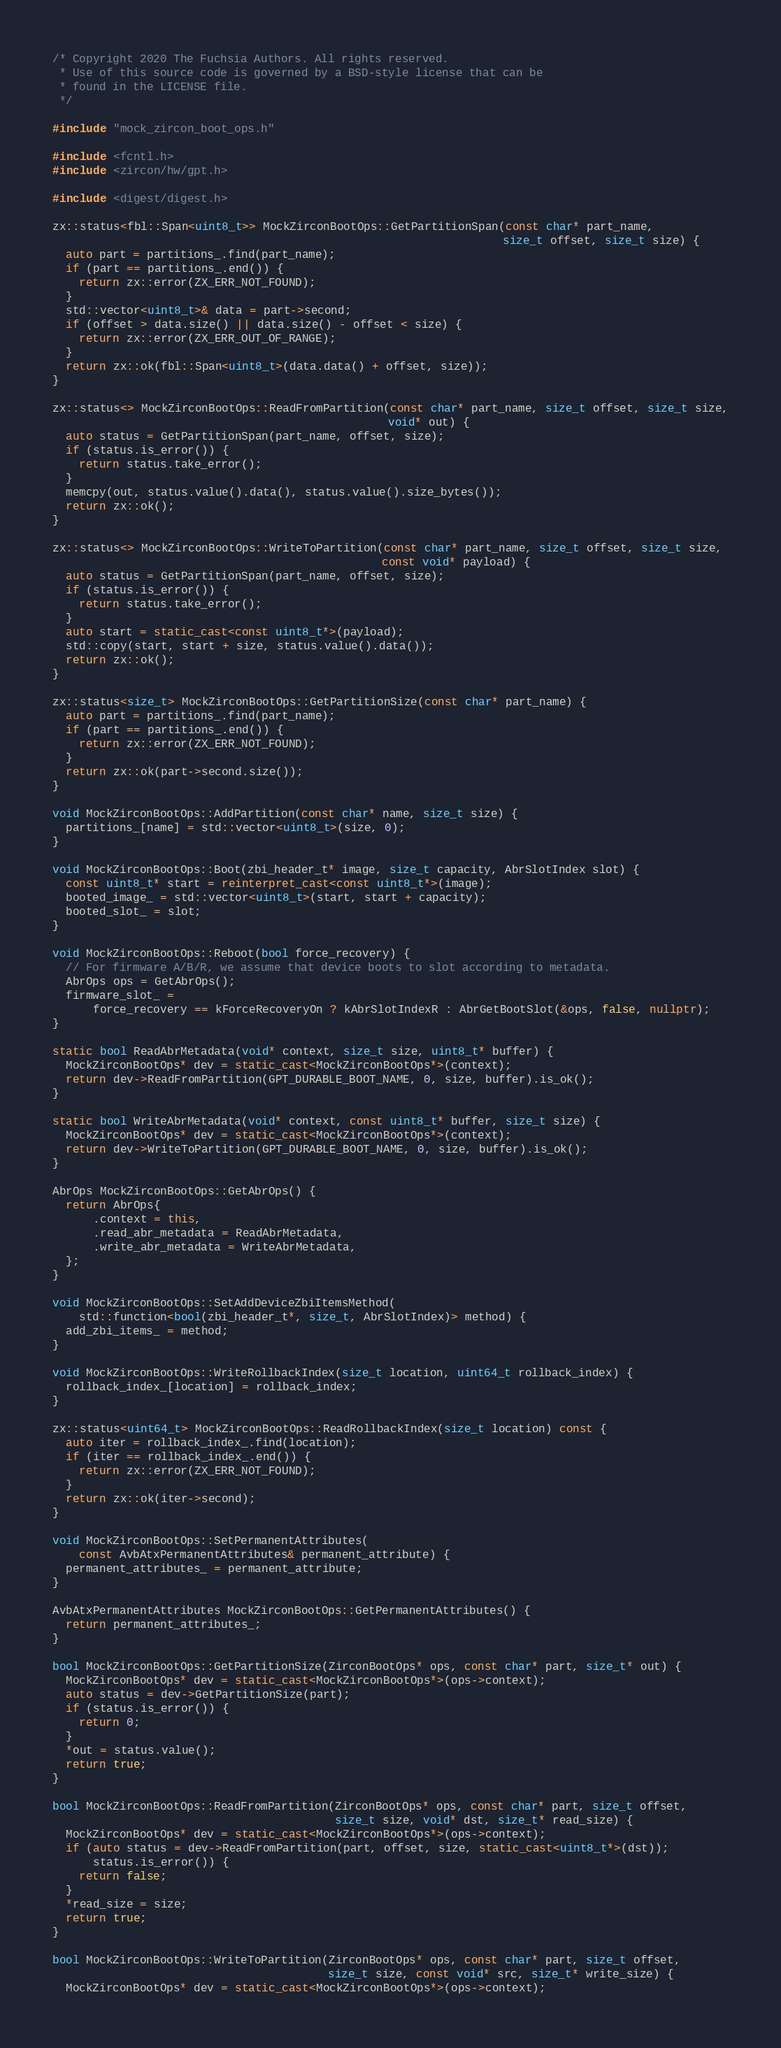<code> <loc_0><loc_0><loc_500><loc_500><_C++_>/* Copyright 2020 The Fuchsia Authors. All rights reserved.
 * Use of this source code is governed by a BSD-style license that can be
 * found in the LICENSE file.
 */

#include "mock_zircon_boot_ops.h"

#include <fcntl.h>
#include <zircon/hw/gpt.h>

#include <digest/digest.h>

zx::status<fbl::Span<uint8_t>> MockZirconBootOps::GetPartitionSpan(const char* part_name,
                                                                   size_t offset, size_t size) {
  auto part = partitions_.find(part_name);
  if (part == partitions_.end()) {
    return zx::error(ZX_ERR_NOT_FOUND);
  }
  std::vector<uint8_t>& data = part->second;
  if (offset > data.size() || data.size() - offset < size) {
    return zx::error(ZX_ERR_OUT_OF_RANGE);
  }
  return zx::ok(fbl::Span<uint8_t>(data.data() + offset, size));
}

zx::status<> MockZirconBootOps::ReadFromPartition(const char* part_name, size_t offset, size_t size,
                                                  void* out) {
  auto status = GetPartitionSpan(part_name, offset, size);
  if (status.is_error()) {
    return status.take_error();
  }
  memcpy(out, status.value().data(), status.value().size_bytes());
  return zx::ok();
}

zx::status<> MockZirconBootOps::WriteToPartition(const char* part_name, size_t offset, size_t size,
                                                 const void* payload) {
  auto status = GetPartitionSpan(part_name, offset, size);
  if (status.is_error()) {
    return status.take_error();
  }
  auto start = static_cast<const uint8_t*>(payload);
  std::copy(start, start + size, status.value().data());
  return zx::ok();
}

zx::status<size_t> MockZirconBootOps::GetPartitionSize(const char* part_name) {
  auto part = partitions_.find(part_name);
  if (part == partitions_.end()) {
    return zx::error(ZX_ERR_NOT_FOUND);
  }
  return zx::ok(part->second.size());
}

void MockZirconBootOps::AddPartition(const char* name, size_t size) {
  partitions_[name] = std::vector<uint8_t>(size, 0);
}

void MockZirconBootOps::Boot(zbi_header_t* image, size_t capacity, AbrSlotIndex slot) {
  const uint8_t* start = reinterpret_cast<const uint8_t*>(image);
  booted_image_ = std::vector<uint8_t>(start, start + capacity);
  booted_slot_ = slot;
}

void MockZirconBootOps::Reboot(bool force_recovery) {
  // For firmware A/B/R, we assume that device boots to slot according to metadata.
  AbrOps ops = GetAbrOps();
  firmware_slot_ =
      force_recovery == kForceRecoveryOn ? kAbrSlotIndexR : AbrGetBootSlot(&ops, false, nullptr);
}

static bool ReadAbrMetadata(void* context, size_t size, uint8_t* buffer) {
  MockZirconBootOps* dev = static_cast<MockZirconBootOps*>(context);
  return dev->ReadFromPartition(GPT_DURABLE_BOOT_NAME, 0, size, buffer).is_ok();
}

static bool WriteAbrMetadata(void* context, const uint8_t* buffer, size_t size) {
  MockZirconBootOps* dev = static_cast<MockZirconBootOps*>(context);
  return dev->WriteToPartition(GPT_DURABLE_BOOT_NAME, 0, size, buffer).is_ok();
}

AbrOps MockZirconBootOps::GetAbrOps() {
  return AbrOps{
      .context = this,
      .read_abr_metadata = ReadAbrMetadata,
      .write_abr_metadata = WriteAbrMetadata,
  };
}

void MockZirconBootOps::SetAddDeviceZbiItemsMethod(
    std::function<bool(zbi_header_t*, size_t, AbrSlotIndex)> method) {
  add_zbi_items_ = method;
}

void MockZirconBootOps::WriteRollbackIndex(size_t location, uint64_t rollback_index) {
  rollback_index_[location] = rollback_index;
}

zx::status<uint64_t> MockZirconBootOps::ReadRollbackIndex(size_t location) const {
  auto iter = rollback_index_.find(location);
  if (iter == rollback_index_.end()) {
    return zx::error(ZX_ERR_NOT_FOUND);
  }
  return zx::ok(iter->second);
}

void MockZirconBootOps::SetPermanentAttributes(
    const AvbAtxPermanentAttributes& permanent_attribute) {
  permanent_attributes_ = permanent_attribute;
}

AvbAtxPermanentAttributes MockZirconBootOps::GetPermanentAttributes() {
  return permanent_attributes_;
}

bool MockZirconBootOps::GetPartitionSize(ZirconBootOps* ops, const char* part, size_t* out) {
  MockZirconBootOps* dev = static_cast<MockZirconBootOps*>(ops->context);
  auto status = dev->GetPartitionSize(part);
  if (status.is_error()) {
    return 0;
  }
  *out = status.value();
  return true;
}

bool MockZirconBootOps::ReadFromPartition(ZirconBootOps* ops, const char* part, size_t offset,
                                          size_t size, void* dst, size_t* read_size) {
  MockZirconBootOps* dev = static_cast<MockZirconBootOps*>(ops->context);
  if (auto status = dev->ReadFromPartition(part, offset, size, static_cast<uint8_t*>(dst));
      status.is_error()) {
    return false;
  }
  *read_size = size;
  return true;
}

bool MockZirconBootOps::WriteToPartition(ZirconBootOps* ops, const char* part, size_t offset,
                                         size_t size, const void* src, size_t* write_size) {
  MockZirconBootOps* dev = static_cast<MockZirconBootOps*>(ops->context);</code> 